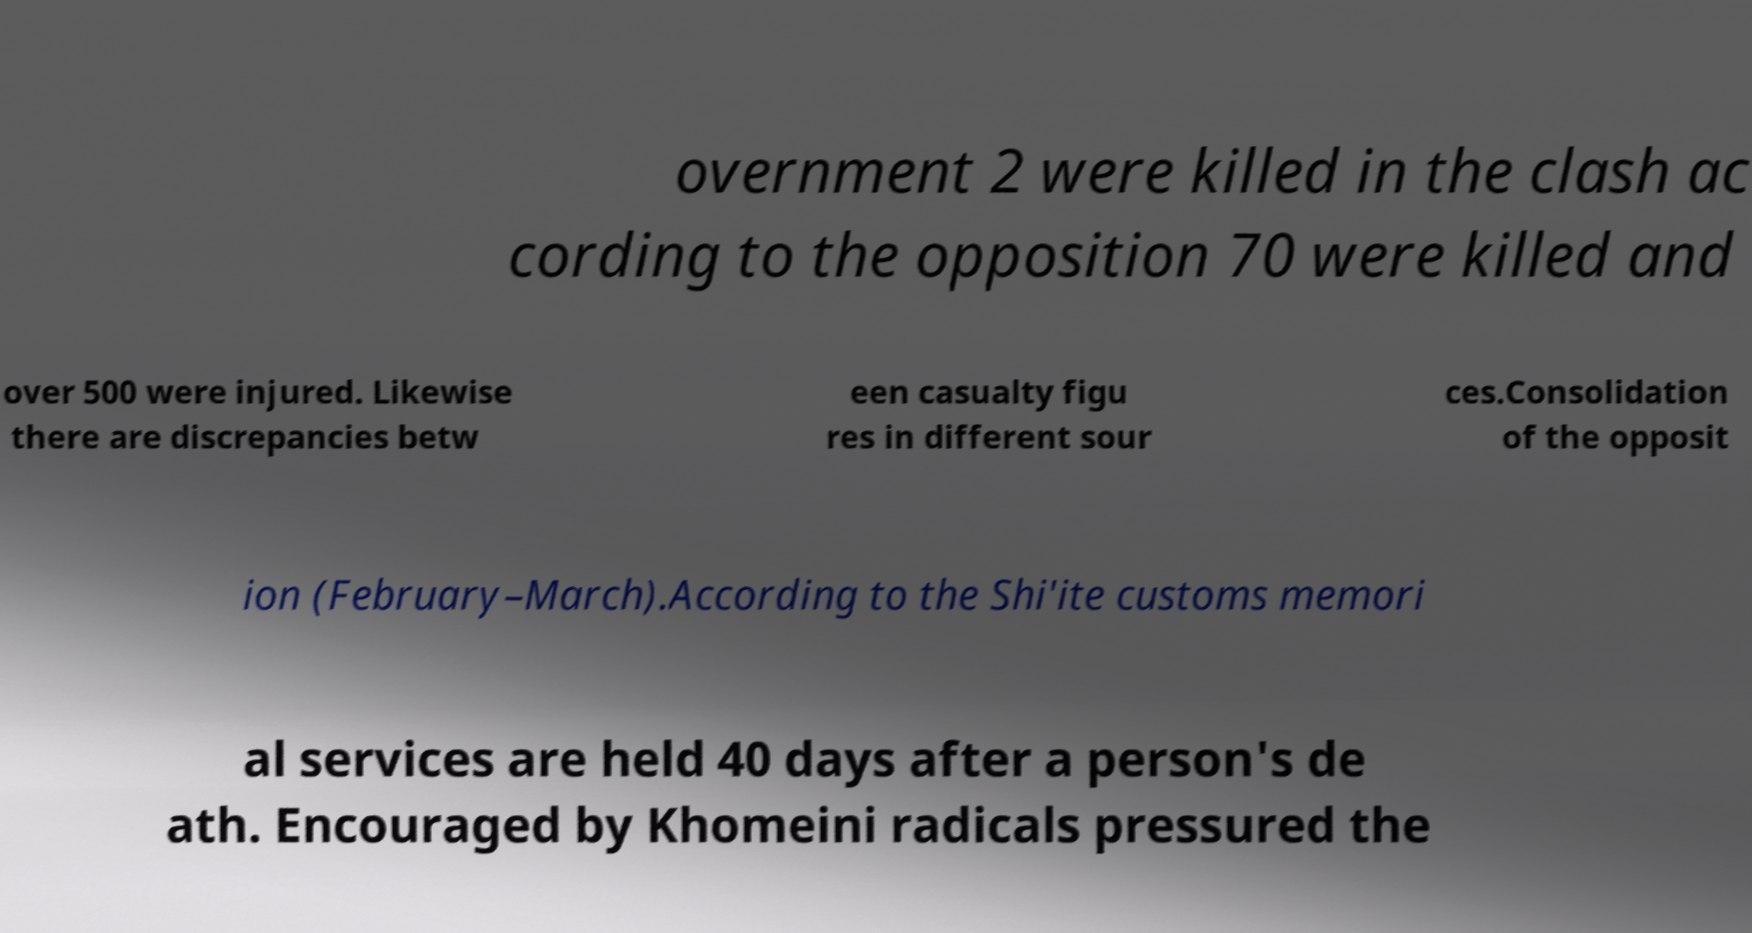There's text embedded in this image that I need extracted. Can you transcribe it verbatim? overnment 2 were killed in the clash ac cording to the opposition 70 were killed and over 500 were injured. Likewise there are discrepancies betw een casualty figu res in different sour ces.Consolidation of the opposit ion (February–March).According to the Shi'ite customs memori al services are held 40 days after a person's de ath. Encouraged by Khomeini radicals pressured the 